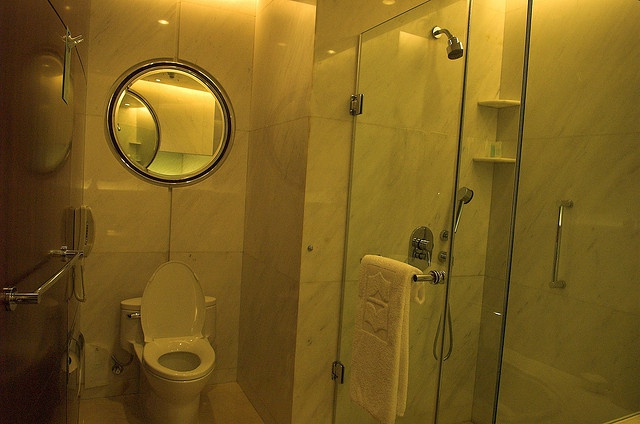Describe the objects in this image and their specific colors. I can see a toilet in maroon, olive, and black tones in this image. 